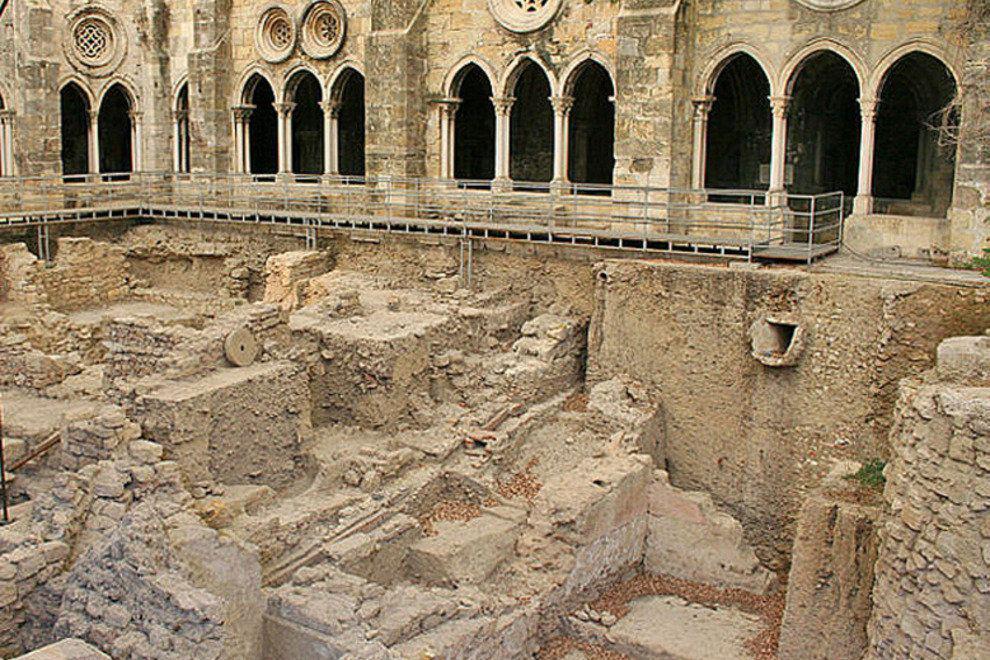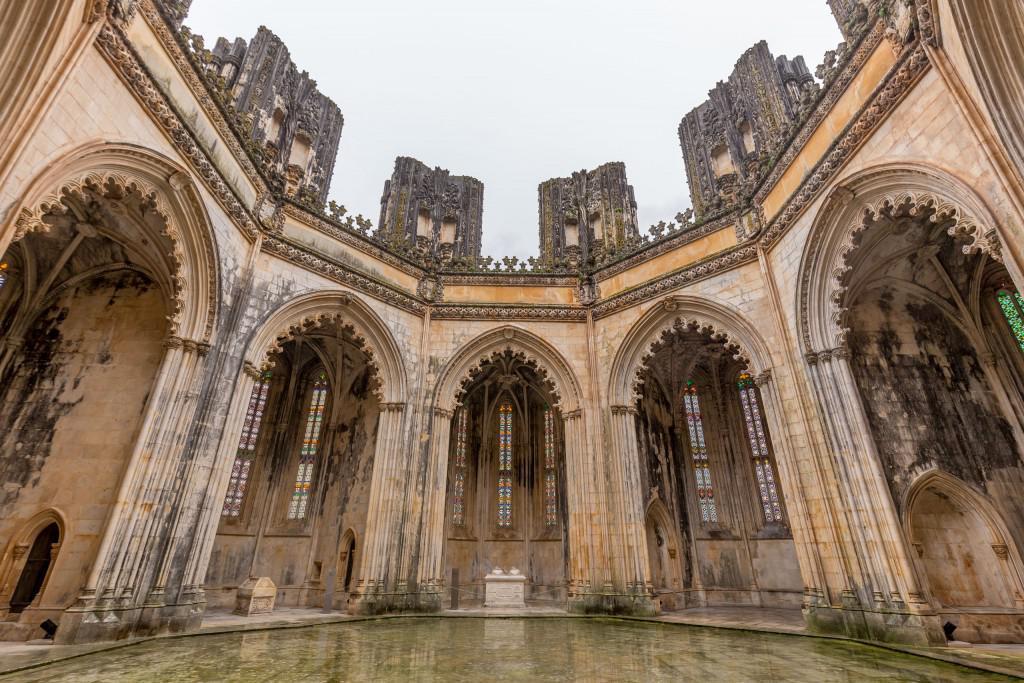The first image is the image on the left, the second image is the image on the right. Examine the images to the left and right. Is the description "An image shows a semi-circle of arches, with an opening above them." accurate? Answer yes or no. Yes. 